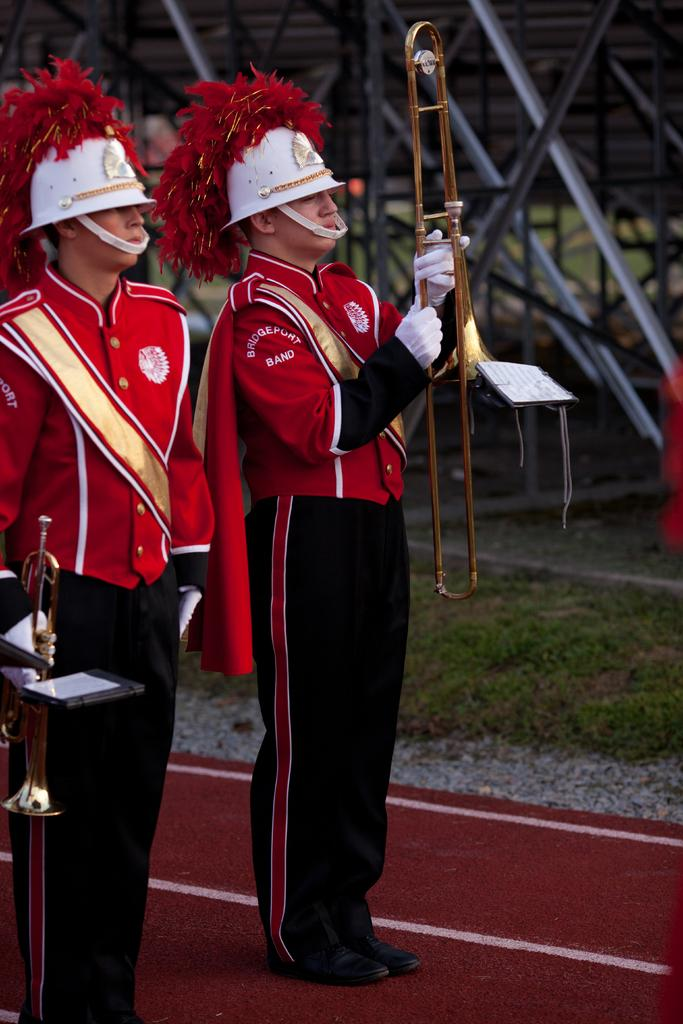<image>
Offer a succinct explanation of the picture presented. Membes of the Birdgeport Band stand on a red track ready to start performing. 